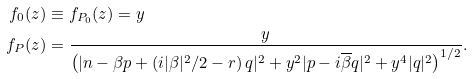Convert formula to latex. <formula><loc_0><loc_0><loc_500><loc_500>f _ { 0 } ( z ) & \equiv f _ { P _ { 0 } } ( z ) = y \\ f _ { P } ( z ) & = \frac { y } { \left ( | n - \beta p + \left ( i | \beta | ^ { 2 } / 2 - r \right ) q | ^ { 2 } + y ^ { 2 } | p - i \overline { \beta } q | ^ { 2 } + y ^ { 4 } | q | ^ { 2 } \right ) ^ { 1 / 2 } } .</formula> 